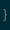Convert code to text. <code><loc_0><loc_0><loc_500><loc_500><_Java_>}
</code> 